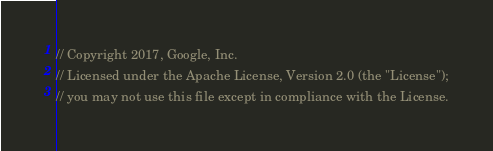<code> <loc_0><loc_0><loc_500><loc_500><_JavaScript_>// Copyright 2017, Google, Inc.
// Licensed under the Apache License, Version 2.0 (the "License");
// you may not use this file except in compliance with the License.</code> 